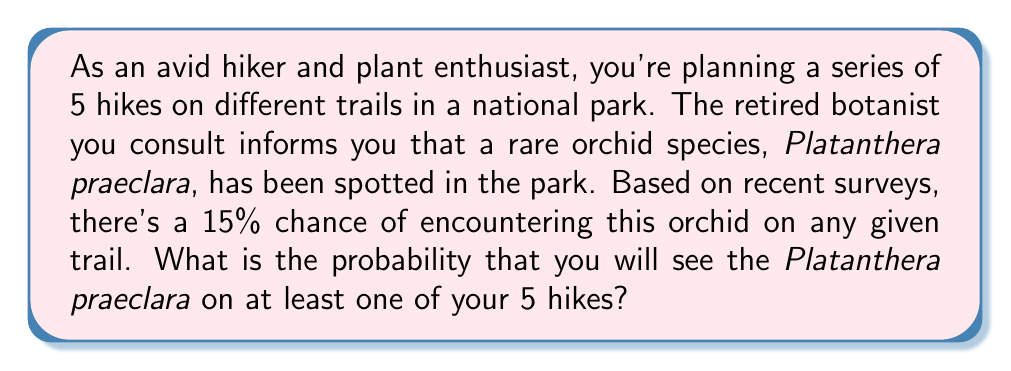What is the answer to this math problem? To solve this problem, we can use the complement rule of probability. Instead of calculating the probability of seeing the orchid on at least one hike, it's easier to calculate the probability of not seeing it on any of the hikes and then subtract that from 1.

Let's break it down step-by-step:

1) The probability of not seeing the orchid on a single trail is:
   $1 - 0.15 = 0.85$ or $85\%$

2) For independent events, we multiply the individual probabilities. So, the probability of not seeing the orchid on all 5 hikes is:
   $$(0.85)^5 = 0.4437$$

3) Therefore, the probability of seeing the orchid on at least one hike is the complement of this:
   $$1 - (0.85)^5 = 1 - 0.4437 = 0.5563$$

We can also express this using the binomial probability formula:

$$P(\text{at least one success}) = 1 - P(\text{no successes})$$
$$= 1 - \binom{5}{0}(0.15)^0(0.85)^5$$
$$= 1 - (1)(1)(0.4437) = 0.5563$$
Answer: The probability of encountering the Platanthera praeclara on at least one of the 5 hikes is approximately 0.5563 or 55.63%. 